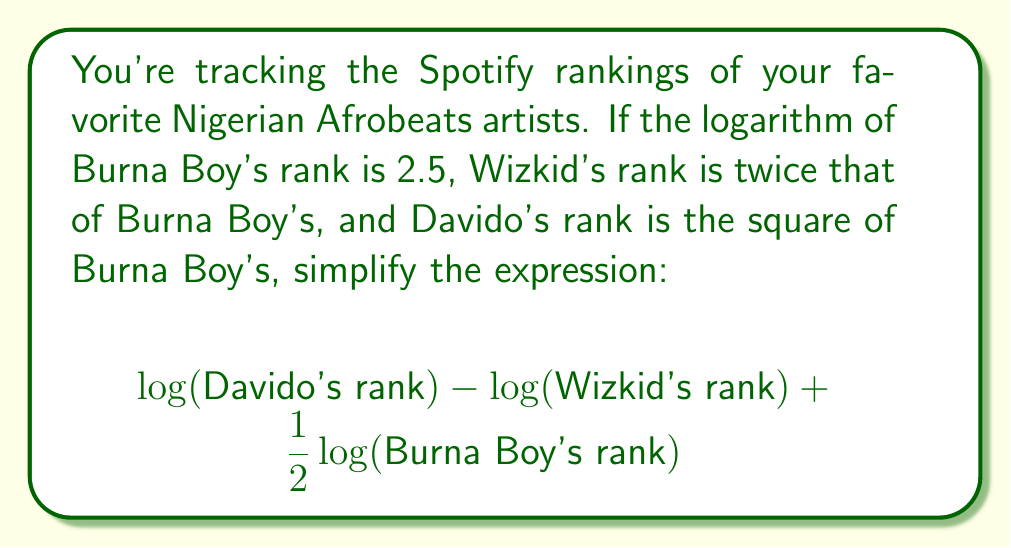Show me your answer to this math problem. Let's approach this step-by-step:

1) First, let's define Burna Boy's rank:
   $$\log(\text{Burna Boy's rank}) = 2.5$$
   $$\text{Burna Boy's rank} = 10^{2.5}$$

2) Wizkid's rank is twice Burna Boy's:
   $$\text{Wizkid's rank} = 2 \cdot 10^{2.5}$$

3) Davido's rank is the square of Burna Boy's:
   $$\text{Davido's rank} = (10^{2.5})^2 = 10^5$$

4) Now, let's substitute these into our expression:
   $$\log(10^5) - \log(2 \cdot 10^{2.5}) + \frac{1}{2}\log(10^{2.5})$$

5) Simplify using logarithm properties:
   $$5 - [\log(2) + \log(10^{2.5})] + \frac{1}{2}(2.5)$$

6) Simplify further:
   $$5 - [\log(2) + 2.5] + 1.25$$

7) Combine like terms:
   $$6.25 - \log(2) - 2.5$$

8) Final simplification:
   $$3.75 - \log(2)$$
Answer: $3.75 - \log(2)$ 